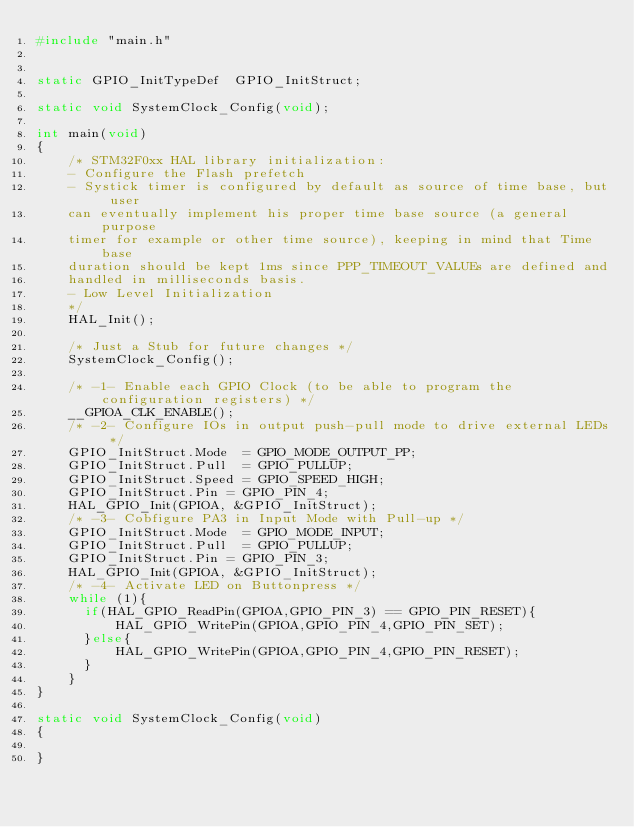<code> <loc_0><loc_0><loc_500><loc_500><_C_>#include "main.h"


static GPIO_InitTypeDef  GPIO_InitStruct;

static void SystemClock_Config(void);

int main(void)
{
	/* STM32F0xx HAL library initialization:
	- Configure the Flash prefetch
	- Systick timer is configured by default as source of time base, but user 
	can eventually implement his proper time base source (a general purpose 
	timer for example or other time source), keeping in mind that Time base 
	duration should be kept 1ms since PPP_TIMEOUT_VALUEs are defined and 
	handled in milliseconds basis.
	- Low Level Initialization
	*/
	HAL_Init();
	
	/* Just a Stub for future changes */
	SystemClock_Config();
	
	/* -1- Enable each GPIO Clock (to be able to program the configuration registers) */
	__GPIOA_CLK_ENABLE();
	/* -2- Configure IOs in output push-pull mode to drive external LEDs */
	GPIO_InitStruct.Mode  = GPIO_MODE_OUTPUT_PP;
	GPIO_InitStruct.Pull  = GPIO_PULLUP;
	GPIO_InitStruct.Speed = GPIO_SPEED_HIGH;
	GPIO_InitStruct.Pin = GPIO_PIN_4;
	HAL_GPIO_Init(GPIOA, &GPIO_InitStruct);
	/* -3- Cobfigure PA3 in Input Mode with Pull-up */
	GPIO_InitStruct.Mode  = GPIO_MODE_INPUT;
	GPIO_InitStruct.Pull  = GPIO_PULLUP;
	GPIO_InitStruct.Pin = GPIO_PIN_3;
	HAL_GPIO_Init(GPIOA, &GPIO_InitStruct);
	/* -4- Activate LED on Buttonpress */
	while (1){
	  if(HAL_GPIO_ReadPin(GPIOA,GPIO_PIN_3) == GPIO_PIN_RESET){
	      HAL_GPIO_WritePin(GPIOA,GPIO_PIN_4,GPIO_PIN_SET);
	  }else{
	      HAL_GPIO_WritePin(GPIOA,GPIO_PIN_4,GPIO_PIN_RESET);
	  }
	}
}

static void SystemClock_Config(void)
{
	
}
</code> 